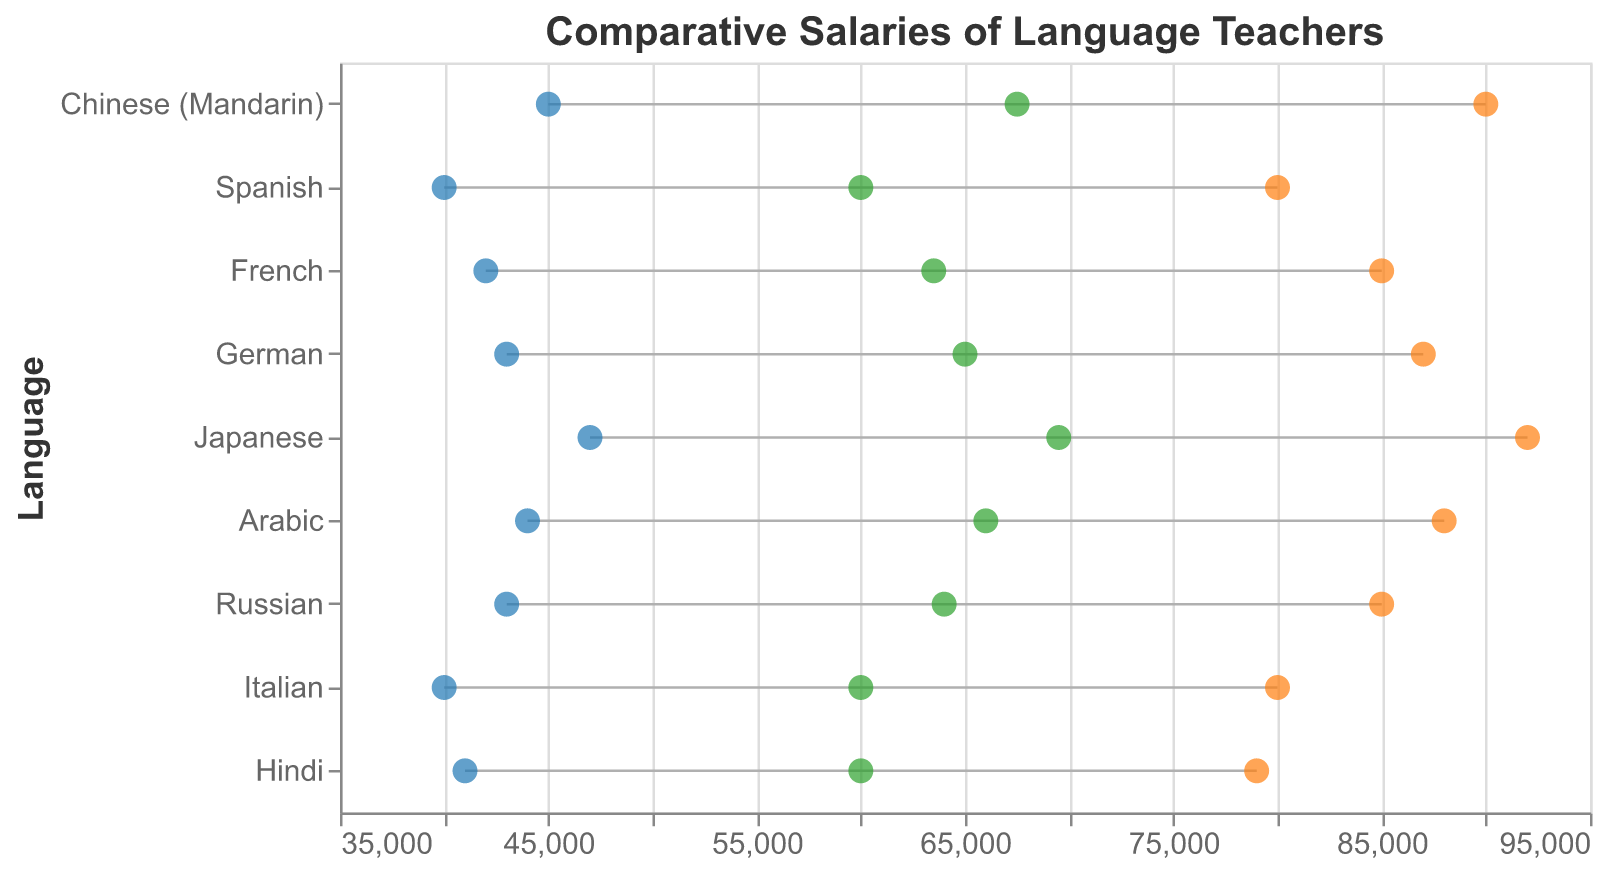What's the title of the plot? The title of the figure is written at the top and should be straightforward to identify.
Answer: Comparative Salaries of Language Teachers What does the color blue represent in the plot? The blue color represents the minimum salary (USD) for each language.
Answer: Minimum Salary (USD) Which language has the highest maximum salary? The highest maximum salary is indicated by the point furthest to the right. For Japanese, the maximum salary is 92000 USD.
Answer: Japanese Which language has the smallest range between the minimum and maximum salaries? To find this, we compare the difference between the maximum and minimum salaries for each language. Hindi has the smallest range (79000 - 41000 = 38000 USD).
Answer: Hindi How does the average salary for Russian compare to the average salary for Chinese (Mandarin)? The plot shows that the average salary for Russian (64000 USD) is lower than that for Chinese (Mandarin) (67500 USD).
Answer: Russian's average salary is lower than Chinese (Mandarin)'s What's the difference between the maximum salary for Spanish and Arabic? The difference can be calculated by subtracting the maximum salary for Spanish (80000 USD) from the maximum salary for Arabic (88000 USD). 88000 - 80000 = 8000 USD.
Answer: 8000 USD Which three languages have the highest average salaries? To determine this, we compare the average salary points. The three languages with the highest average salaries are Japanese (69500 USD), Chinese (Mandarin) (67500 USD), and Arabic (66000 USD).
Answer: Japanese, Chinese (Mandarin), and Arabic What is the mean value of the average salaries across all languages? First, sum up all the average salaries and divide by the number of languages. (67500 + 60000 + 63500 + 65000 + 69500 + 66000 + 64000 + 60000 + 60000) / 9 = 61956 USD.
Answer: 61956 USD Which language’s teachers earn a minimum salary that is higher than the average salary for Italian teachers? We need to compare the minimum salaries with the average salary for Italian teachers (60000 USD). Chinese (Mandarin) and Japanese have minimum salaries of 45000 USD and 47000 USD, both above 60000 USD.
Answer: Chinese (Mandarin) and Japanese 